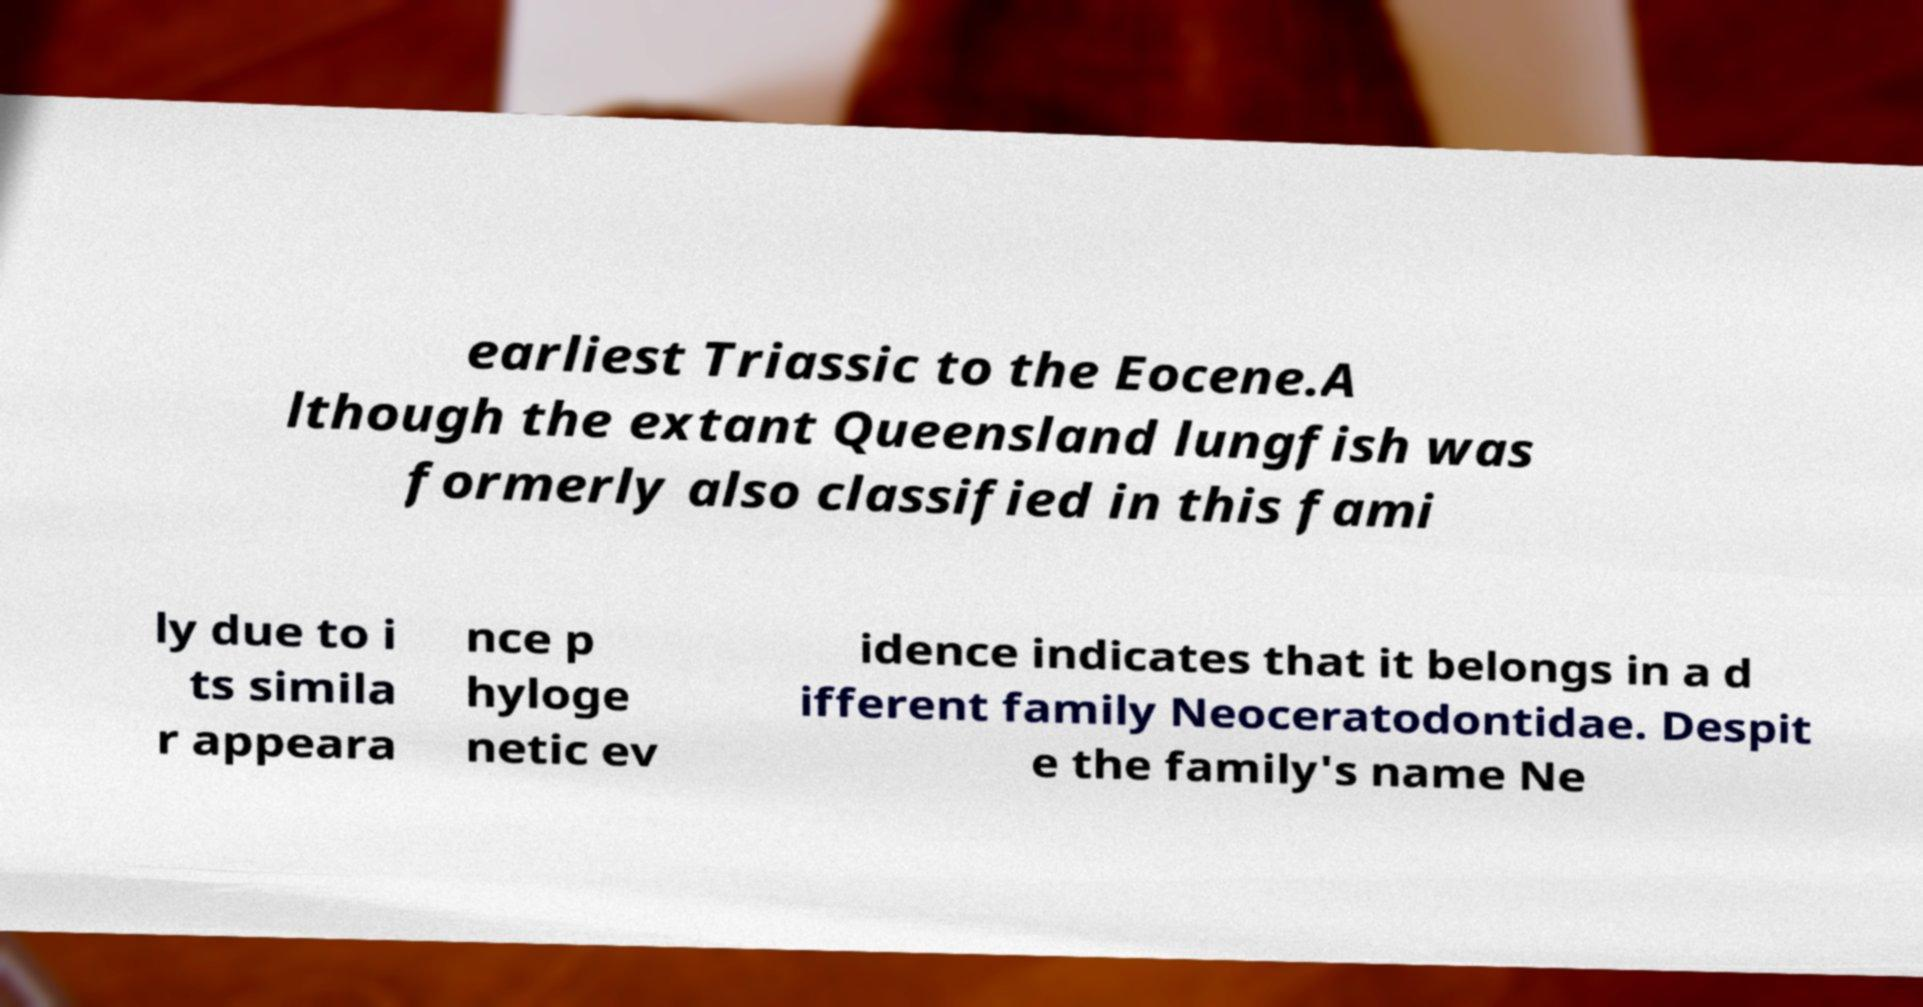Could you extract and type out the text from this image? earliest Triassic to the Eocene.A lthough the extant Queensland lungfish was formerly also classified in this fami ly due to i ts simila r appeara nce p hyloge netic ev idence indicates that it belongs in a d ifferent family Neoceratodontidae. Despit e the family's name Ne 